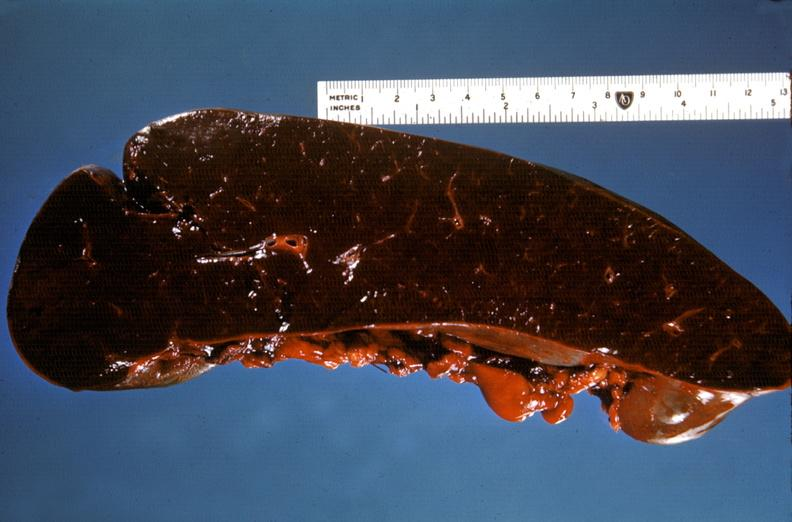what does this image show?
Answer the question using a single word or phrase. Spleen 